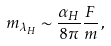Convert formula to latex. <formula><loc_0><loc_0><loc_500><loc_500>m _ { \lambda _ { H } } \sim \frac { \alpha _ { H } } { 8 \pi } \frac { F } { m } \, ,</formula> 